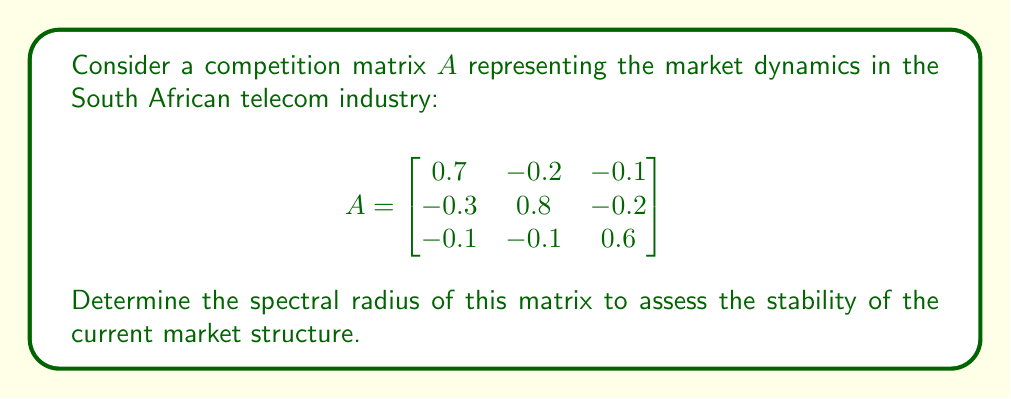Teach me how to tackle this problem. To determine the spectral radius of the competition matrix $A$, we need to follow these steps:

1) First, we need to find the eigenvalues of the matrix $A$. The characteristic equation is:

   $\det(A - \lambda I) = 0$

2) Expanding this determinant:

   $$\begin{vmatrix}
   0.7-\lambda & -0.2 & -0.1 \\
   -0.3 & 0.8-\lambda & -0.2 \\
   -0.1 & -0.1 & 0.6-\lambda
   \end{vmatrix} = 0$$

3) This gives us the cubic equation:

   $-\lambda^3 + 2.1\lambda^2 - 1.33\lambda + 0.254 = 0$

4) Solving this equation (using numerical methods or a computer algebra system), we get the eigenvalues:

   $\lambda_1 \approx 0.9827$
   $\lambda_2 \approx 0.6087$
   $\lambda_3 \approx 0.5086$

5) The spectral radius $\rho(A)$ is defined as the maximum absolute value of the eigenvalues:

   $\rho(A) = \max\{|\lambda_1|, |\lambda_2|, |\lambda_3|\}$

6) Therefore, the spectral radius is approximately 0.9827.

7) Since the spectral radius is less than 1, this indicates that the market structure is stable. However, being close to 1 suggests that the market is highly competitive and near a tipping point.
Answer: $\rho(A) \approx 0.9827$ 